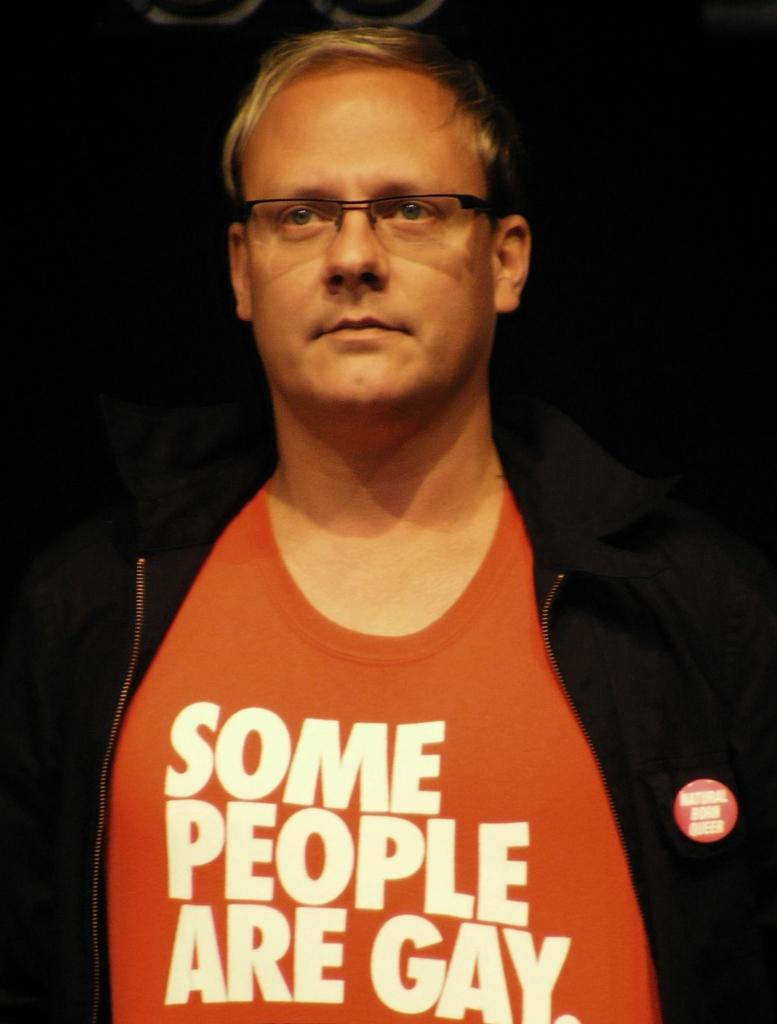What can be seen in the image? There is a person in the image. Can you describe the person's appearance? The person is wearing spectacles. What type of credit does the person have in the image? There is no mention of credit in the image, as it only shows a person wearing spectacles. Can you see any dust in the image? There is no indication of dust in the image, as it only shows a person wearing spectacles. 